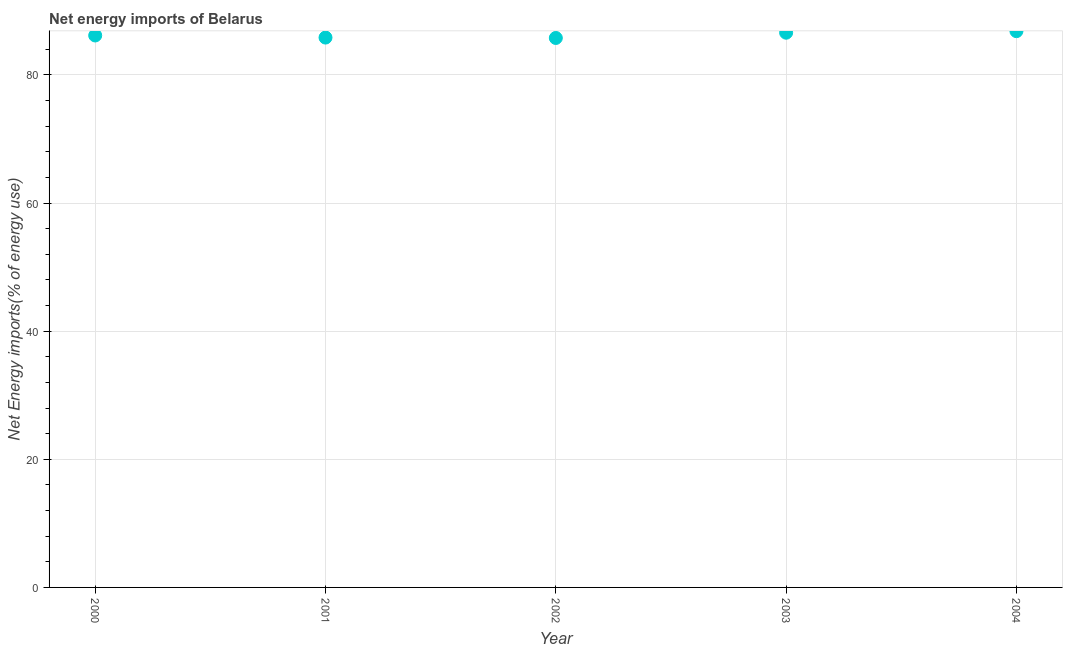What is the energy imports in 2004?
Provide a short and direct response. 86.84. Across all years, what is the maximum energy imports?
Keep it short and to the point. 86.84. Across all years, what is the minimum energy imports?
Offer a terse response. 85.78. In which year was the energy imports maximum?
Your answer should be compact. 2004. In which year was the energy imports minimum?
Your answer should be very brief. 2002. What is the sum of the energy imports?
Keep it short and to the point. 431.22. What is the difference between the energy imports in 2000 and 2004?
Offer a very short reply. -0.67. What is the average energy imports per year?
Give a very brief answer. 86.24. What is the median energy imports?
Make the answer very short. 86.17. Do a majority of the years between 2003 and 2002 (inclusive) have energy imports greater than 80 %?
Offer a very short reply. No. What is the ratio of the energy imports in 2000 to that in 2003?
Offer a very short reply. 1. Is the difference between the energy imports in 2002 and 2004 greater than the difference between any two years?
Provide a succinct answer. Yes. What is the difference between the highest and the second highest energy imports?
Your answer should be very brief. 0.24. What is the difference between the highest and the lowest energy imports?
Your response must be concise. 1.06. How many years are there in the graph?
Give a very brief answer. 5. What is the difference between two consecutive major ticks on the Y-axis?
Keep it short and to the point. 20. Does the graph contain any zero values?
Your answer should be compact. No. What is the title of the graph?
Give a very brief answer. Net energy imports of Belarus. What is the label or title of the Y-axis?
Provide a short and direct response. Net Energy imports(% of energy use). What is the Net Energy imports(% of energy use) in 2000?
Offer a very short reply. 86.17. What is the Net Energy imports(% of energy use) in 2001?
Provide a succinct answer. 85.84. What is the Net Energy imports(% of energy use) in 2002?
Keep it short and to the point. 85.78. What is the Net Energy imports(% of energy use) in 2003?
Your response must be concise. 86.6. What is the Net Energy imports(% of energy use) in 2004?
Provide a succinct answer. 86.84. What is the difference between the Net Energy imports(% of energy use) in 2000 and 2001?
Offer a terse response. 0.33. What is the difference between the Net Energy imports(% of energy use) in 2000 and 2002?
Make the answer very short. 0.39. What is the difference between the Net Energy imports(% of energy use) in 2000 and 2003?
Your response must be concise. -0.43. What is the difference between the Net Energy imports(% of energy use) in 2000 and 2004?
Give a very brief answer. -0.67. What is the difference between the Net Energy imports(% of energy use) in 2001 and 2002?
Make the answer very short. 0.06. What is the difference between the Net Energy imports(% of energy use) in 2001 and 2003?
Provide a short and direct response. -0.76. What is the difference between the Net Energy imports(% of energy use) in 2001 and 2004?
Ensure brevity in your answer.  -1. What is the difference between the Net Energy imports(% of energy use) in 2002 and 2003?
Offer a very short reply. -0.82. What is the difference between the Net Energy imports(% of energy use) in 2002 and 2004?
Provide a short and direct response. -1.06. What is the difference between the Net Energy imports(% of energy use) in 2003 and 2004?
Keep it short and to the point. -0.24. What is the ratio of the Net Energy imports(% of energy use) in 2000 to that in 2004?
Make the answer very short. 0.99. What is the ratio of the Net Energy imports(% of energy use) in 2001 to that in 2002?
Your response must be concise. 1. What is the ratio of the Net Energy imports(% of energy use) in 2001 to that in 2004?
Your answer should be compact. 0.99. What is the ratio of the Net Energy imports(% of energy use) in 2002 to that in 2003?
Keep it short and to the point. 0.99. What is the ratio of the Net Energy imports(% of energy use) in 2003 to that in 2004?
Give a very brief answer. 1. 